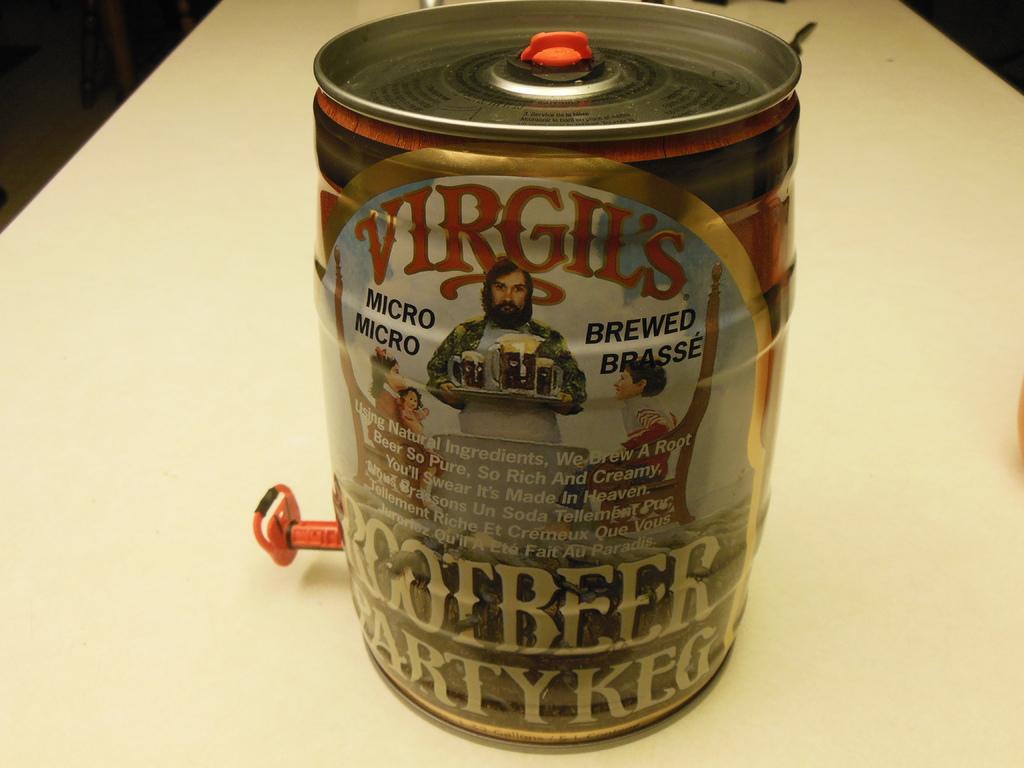What kind of brewed is the beverage?
Your answer should be compact. Root beer. What is the micro brewed brand?
Provide a succinct answer. Virgil's. 